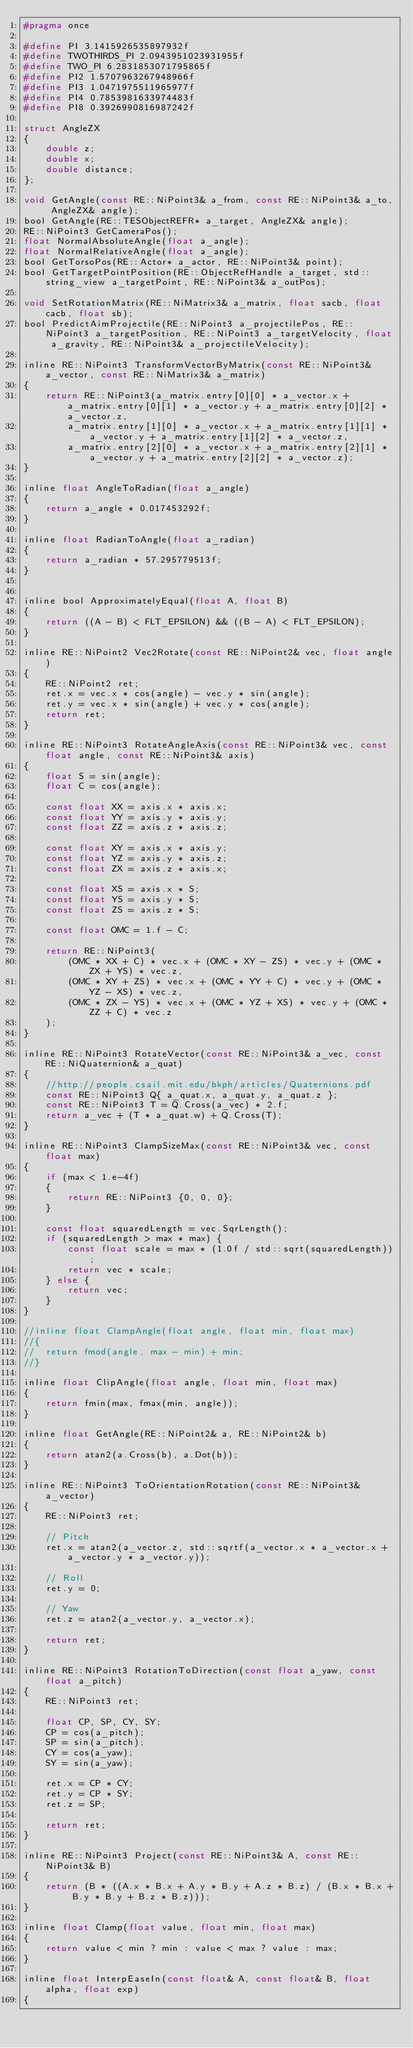<code> <loc_0><loc_0><loc_500><loc_500><_C_>#pragma once

#define PI 3.1415926535897932f
#define TWOTHIRDS_PI 2.0943951023931955f
#define TWO_PI 6.2831853071795865f
#define PI2 1.5707963267948966f
#define PI3 1.0471975511965977f
#define PI4 0.7853981633974483f
#define PI8 0.3926990816987242f

struct AngleZX
{
	double z;
	double x;
	double distance;
};

void GetAngle(const RE::NiPoint3& a_from, const RE::NiPoint3& a_to, AngleZX& angle);
bool GetAngle(RE::TESObjectREFR* a_target, AngleZX& angle);
RE::NiPoint3 GetCameraPos();
float NormalAbsoluteAngle(float a_angle);
float NormalRelativeAngle(float a_angle);
bool GetTorsoPos(RE::Actor* a_actor, RE::NiPoint3& point);
bool GetTargetPointPosition(RE::ObjectRefHandle a_target, std::string_view a_targetPoint, RE::NiPoint3& a_outPos);

void SetRotationMatrix(RE::NiMatrix3& a_matrix, float sacb, float cacb, float sb);
bool PredictAimProjectile(RE::NiPoint3 a_projectilePos, RE::NiPoint3 a_targetPosition, RE::NiPoint3 a_targetVelocity, float a_gravity, RE::NiPoint3& a_projectileVelocity);

inline RE::NiPoint3 TransformVectorByMatrix(const RE::NiPoint3& a_vector, const RE::NiMatrix3& a_matrix)
{
	return RE::NiPoint3(a_matrix.entry[0][0] * a_vector.x + a_matrix.entry[0][1] * a_vector.y + a_matrix.entry[0][2] * a_vector.z,
		a_matrix.entry[1][0] * a_vector.x + a_matrix.entry[1][1] * a_vector.y + a_matrix.entry[1][2] * a_vector.z,
		a_matrix.entry[2][0] * a_vector.x + a_matrix.entry[2][1] * a_vector.y + a_matrix.entry[2][2] * a_vector.z);
}

inline float AngleToRadian(float a_angle)
{
	return a_angle * 0.017453292f;
}

inline float RadianToAngle(float a_radian)
{
	return a_radian * 57.295779513f;
}


inline bool ApproximatelyEqual(float A, float B)
{
	return ((A - B) < FLT_EPSILON) && ((B - A) < FLT_EPSILON);
}

inline RE::NiPoint2 Vec2Rotate(const RE::NiPoint2& vec, float angle)
{
	RE::NiPoint2 ret;
	ret.x = vec.x * cos(angle) - vec.y * sin(angle);
	ret.y = vec.x * sin(angle) + vec.y * cos(angle);
	return ret;
}

inline RE::NiPoint3 RotateAngleAxis(const RE::NiPoint3& vec, const float angle, const RE::NiPoint3& axis)
{
	float S = sin(angle);
	float C = cos(angle);

	const float XX = axis.x * axis.x;
	const float YY = axis.y * axis.y;
	const float ZZ = axis.z * axis.z;

	const float XY = axis.x * axis.y;
	const float YZ = axis.y * axis.z;
	const float ZX = axis.z * axis.x;

	const float XS = axis.x * S;
	const float YS = axis.y * S;
	const float ZS = axis.z * S;

	const float OMC = 1.f - C;

	return RE::NiPoint3(
		(OMC * XX + C) * vec.x + (OMC * XY - ZS) * vec.y + (OMC * ZX + YS) * vec.z,
		(OMC * XY + ZS) * vec.x + (OMC * YY + C) * vec.y + (OMC * YZ - XS) * vec.z,
		(OMC * ZX - YS) * vec.x + (OMC * YZ + XS) * vec.y + (OMC * ZZ + C) * vec.z
	);
}

inline RE::NiPoint3 RotateVector(const RE::NiPoint3& a_vec, const RE::NiQuaternion& a_quat)
{
	//http://people.csail.mit.edu/bkph/articles/Quaternions.pdf
	const RE::NiPoint3 Q{ a_quat.x, a_quat.y, a_quat.z };
	const RE::NiPoint3 T = Q.Cross(a_vec) * 2.f;
	return a_vec + (T * a_quat.w) + Q.Cross(T);
}

inline RE::NiPoint3 ClampSizeMax(const RE::NiPoint3& vec, const float max)
{
	if (max < 1.e-4f)
	{
		return RE::NiPoint3 {0, 0, 0};
	}

	const float squaredLength = vec.SqrLength();
	if (squaredLength > max * max) {
		const float scale = max * (1.0f / std::sqrt(squaredLength));
		return vec * scale;
	} else {
		return vec;
	}
}

//inline float ClampAngle(float angle, float min, float max)
//{
//	return fmod(angle, max - min) + min;
//}

inline float ClipAngle(float angle, float min, float max)
{
	return fmin(max, fmax(min, angle));
}

inline float GetAngle(RE::NiPoint2& a, RE::NiPoint2& b)
{
	return atan2(a.Cross(b), a.Dot(b));
}

inline RE::NiPoint3 ToOrientationRotation(const RE::NiPoint3& a_vector)
{
	RE::NiPoint3 ret;

	// Pitch
	ret.x = atan2(a_vector.z, std::sqrtf(a_vector.x * a_vector.x + a_vector.y * a_vector.y));

	// Roll
	ret.y = 0;

	// Yaw
	ret.z = atan2(a_vector.y, a_vector.x);

	return ret;
}

inline RE::NiPoint3 RotationToDirection(const float a_yaw, const float a_pitch)
{
	RE::NiPoint3 ret;

	float CP, SP, CY, SY;
	CP = cos(a_pitch);
	SP = sin(a_pitch);
	CY = cos(a_yaw);
	SY = sin(a_yaw);

	ret.x = CP * CY;
	ret.y = CP * SY;
	ret.z = SP;

	return ret;
}

inline RE::NiPoint3 Project(const RE::NiPoint3& A, const RE::NiPoint3& B)
{
	return (B * ((A.x * B.x + A.y * B.y + A.z * B.z) / (B.x * B.x + B.y * B.y + B.z * B.z)));
}

inline float Clamp(float value, float min, float max)
{
	return value < min ? min : value < max ? value : max;
}

inline float InterpEaseIn(const float& A, const float& B, float alpha, float exp)
{</code> 